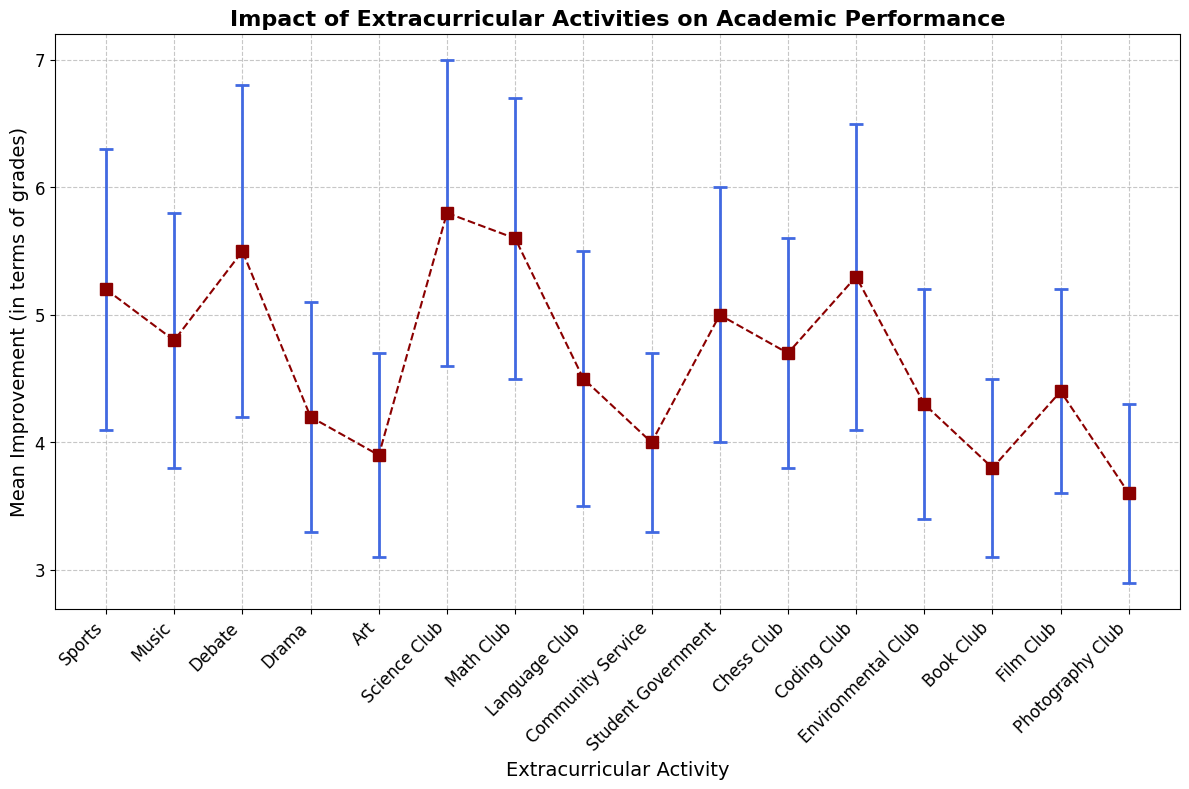Which extracurricular activity has the highest mean improvement in academic performance? By examining the plot, we identify the activity with the highest point vertically on the y-axis, which is labeled along the x-axis. "Science Club" is the tallest.
Answer: Science Club What is the mean improvement for Debate and Coding Club combined? First, find the mean improvements for Debate (5.5) and Coding Club (5.3). Then add these values together: 5.5 + 5.3 = 10.8.
Answer: 10.8 Which activity has the lowest mean improvement in academic performance? Look for the activity with the lowest plotted point vertically on the y-axis. The "Photography Club" has the lowest mean improvement.
Answer: Photography Club Is the mean improvement of Drama greater than Music? Compare the vertical positions of the points for Drama and Music. Drama has a mean improvement of 4.2, Music has 4.8, therefore, Music is greater.
Answer: No What is the difference in mean improvement between Math Club and Art? Locate the mean improvements for Math Club (5.6) and Art (3.9). Subtract Art’s value from Math Club’s: 5.6 - 3.9 = 1.7.
Answer: 1.7 How many activities have a mean improvement above 5? Identify the points above the horizontal line at y=5 and count them. The activities are Sports, Debate, Science Club, Math Club, and Coding Club. So, 5 activities.
Answer: 5 Which activity has the largest standard deviation? Find the error bars representing standard deviation and see which one extends furthest vertically. The "Debate" activity has the largest error bars.
Answer: Debate Are there any activities with the same mean improvement? Check if any vertical points align perfectly horizontally. "Student Government" and "Music" both have a mean improvement of 5.0.
Answer: Yes What is the average mean improvement of the activities that fall under 4.5? Find mean improvements for activities under 4.5 (Drama: 4.2, Art: 3.9, Community Service: 4.0, Chess Club: 4.7, Environmental Club: 4.3, Book Club: 3.8, Film Club: 4.4, Photography Club: 3.6), and calculate the new values: (4.2 + 3.9 + 4.0 + 4.3 + 3.8 + 4.4 + 3.6)/7 ≈ 4.03.
Answer: 4.03 